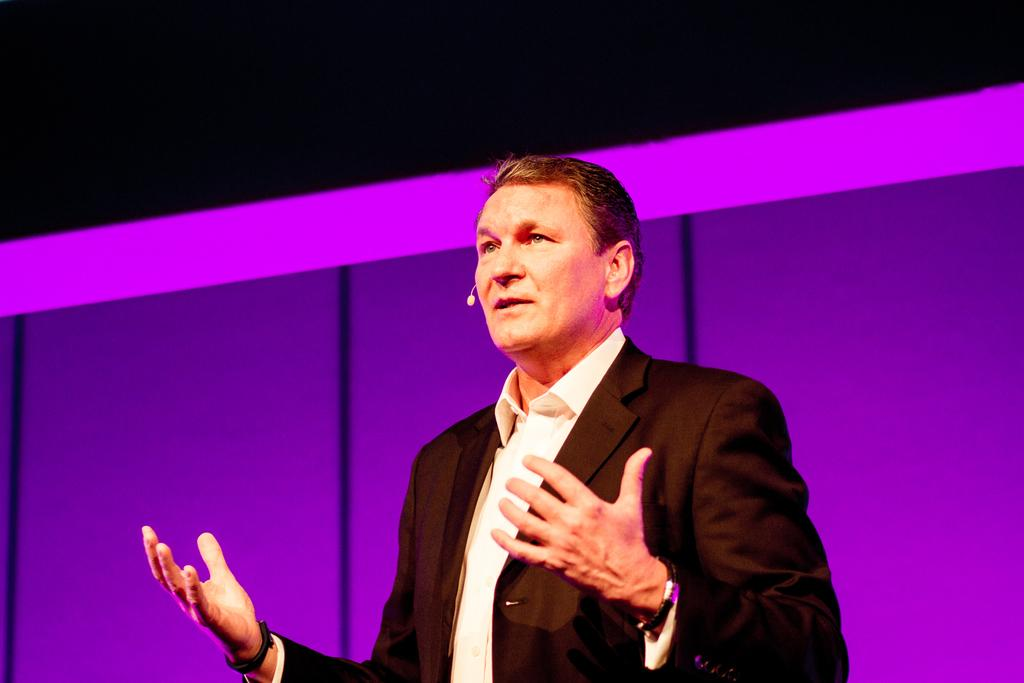What is the main subject of the image? There is a person in the image. What is the person doing in the image? The person is standing. What can be seen on the person in the image? The person is wearing a mic. How many screws can be seen on the person's clothing in the image? There are no screws visible on the person's clothing in the image. What type of light is illuminating the person in the image? There is no specific light source mentioned or visible in the image. 